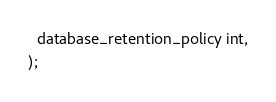<code> <loc_0><loc_0><loc_500><loc_500><_SQL_>  database_retention_policy int,
);
</code> 